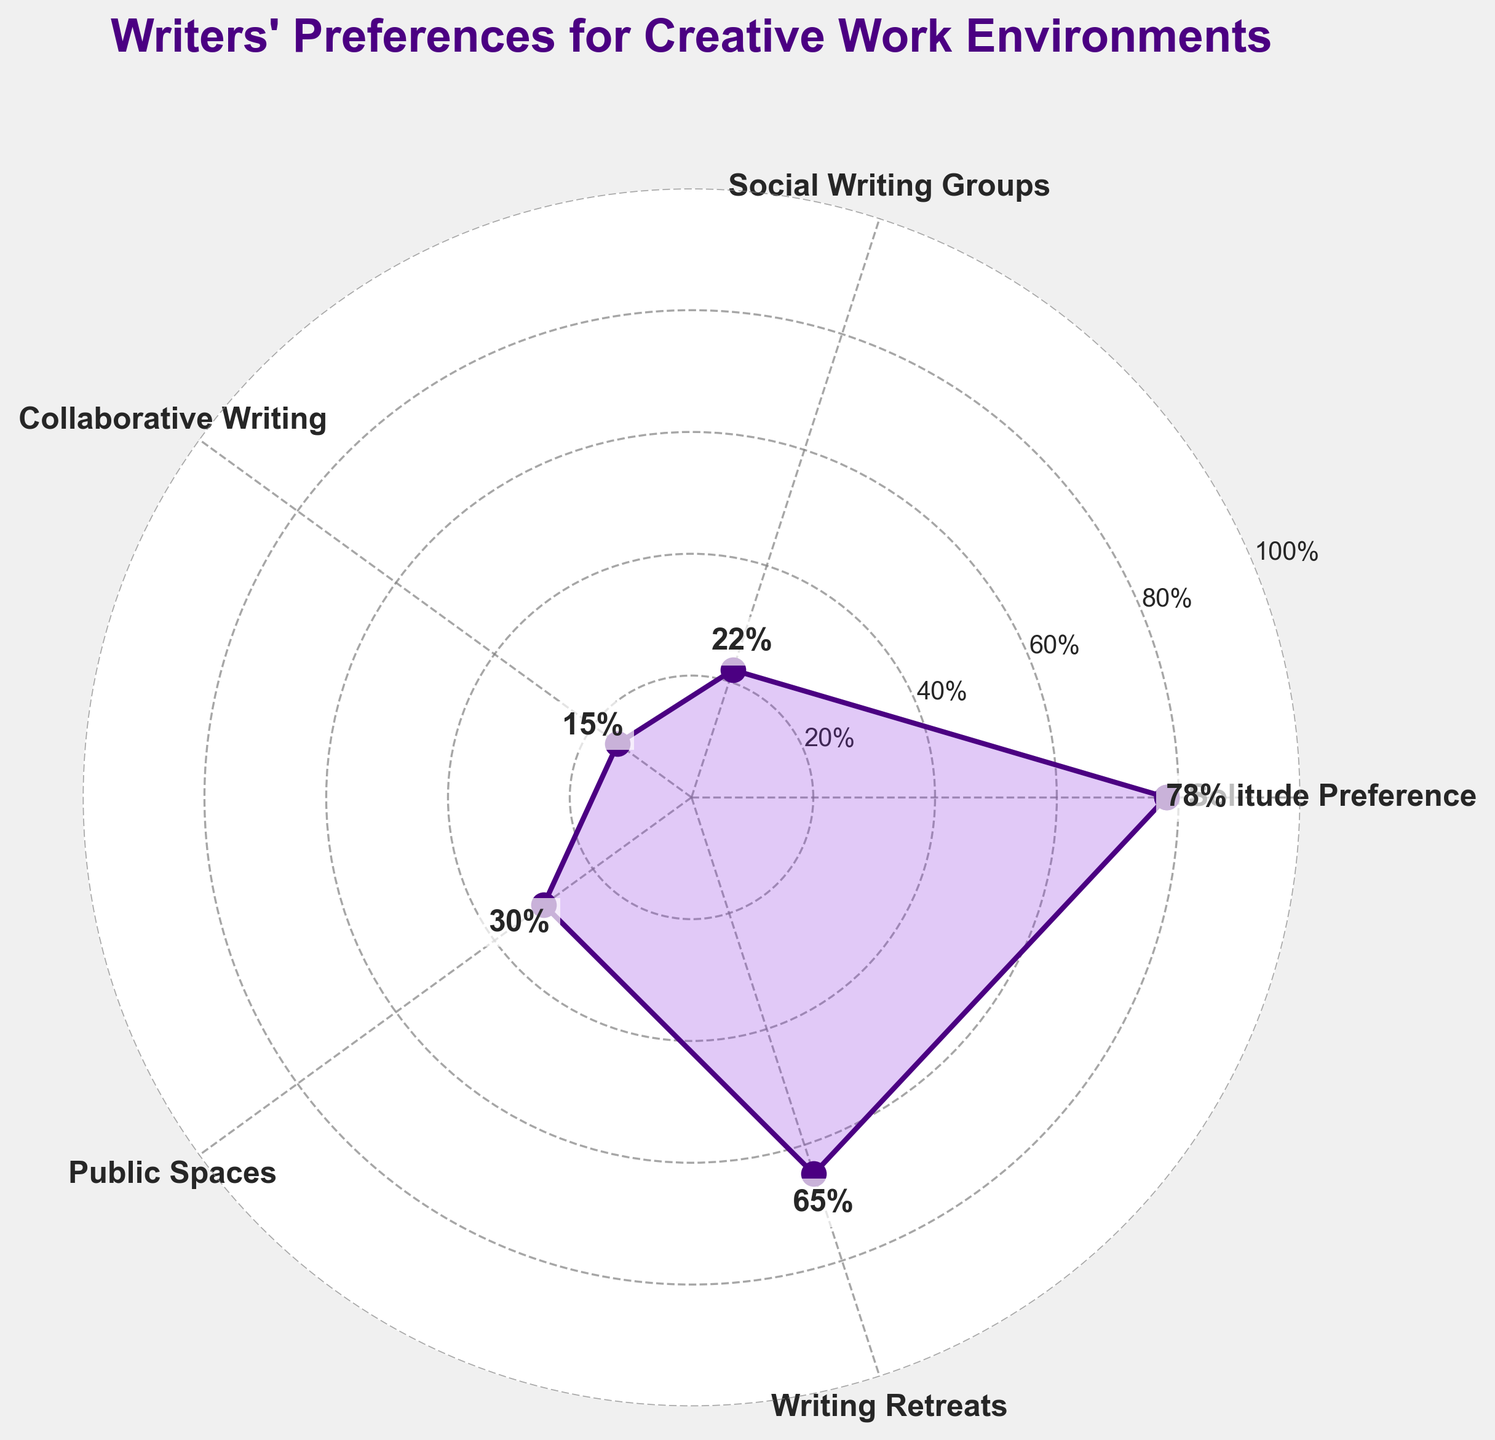what is the title of the figure? The title is usually located at the top of the chart. In this figure, it reads "Writers' Preferences for Creative Work Environments".
Answer: Writers' Preferences for Creative Work Environments Which data point has the highest percentage? By examining the labeled data points, the "Solitude Preference" category has the highest value at 78%.
Answer: Solitude Preference What is the percentage value for Creative Writing Retreats? The labeled data point for "Writing Retreats" is indicated at 65%. This is next to the "Writing Retreats" marker.
Answer: 65% How many categories of writing environments are presented in the chart? The radial chart shows labels for five categories: Solitude Preference, Social Writing Groups, Collaborative Writing, Public Spaces, and Writing Retreats.
Answer: Five What is the value difference between "Collaboration Writing" and "Public Spaces"? The percentage for "Collaborative Writing" is 15%, and for "Public Spaces" it is 30%. The difference is calculated as 30% - 15%.
Answer: 15% Rank the categories from the highest to lowest preference. The percentages for each category can be listed and then sorted: Solitude Preference (78%), Writing Retreats (65%), Public Spaces (30%), Social Writing Groups (22%), and Collaborative Writing (15%).
Answer: Solitude Preference, Writing Retreats, Public Spaces, Social Writing Groups, Collaborative Writing What is the average percentage for all categories? To find the average, sum all percentages and divide by the number of categories: (78% + 22% + 15% + 30% + 65%) / 5 = 210 / 5.
Answer: 42% Which categories' percentages are lower than 30%? Both "Collaborative Writing" with 15% and "Social Writing Groups" with 22% have percentages under 30%.
Answer: Collaborative Writing, Social Writing Groups Is the percentage preference for solitude higher or lower than the combined percentages of other categories? Adding the percentages of the other four categories: (22% + 15% + 30% + 65%) totals 132%, which is higher than 78%.
Answer: Lower 